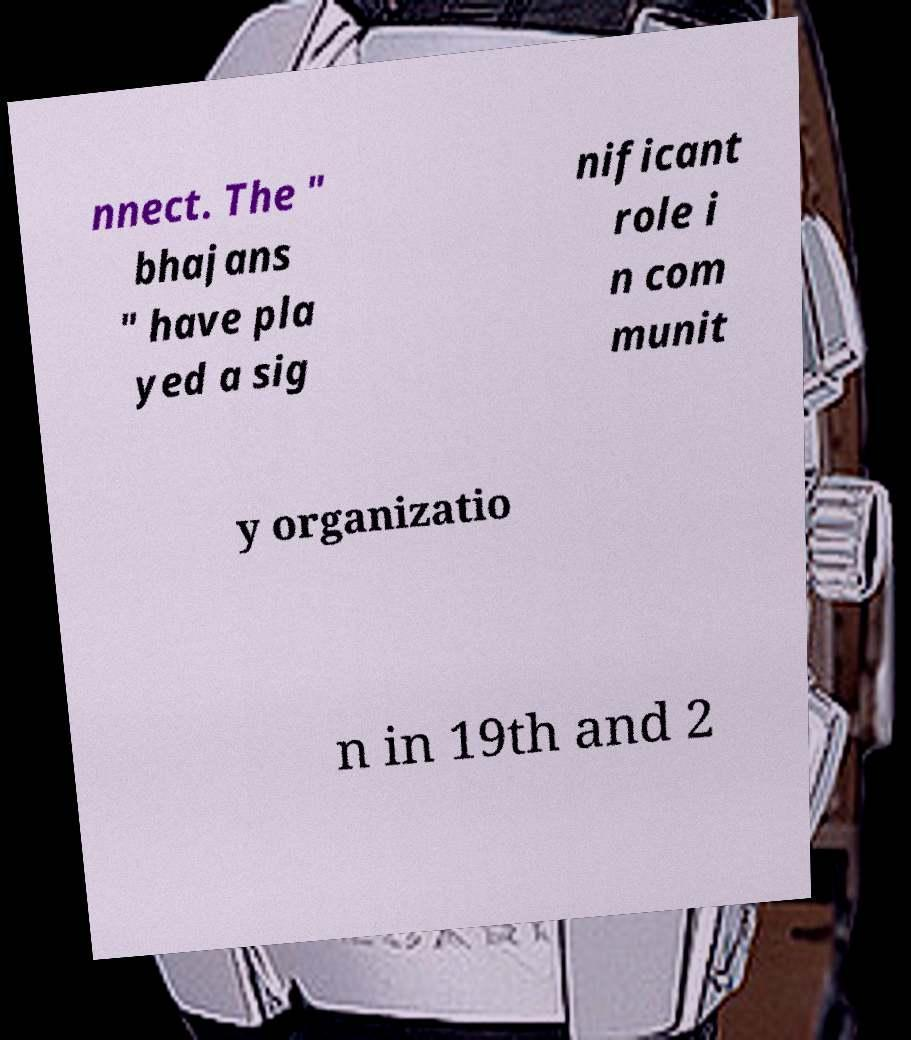Could you assist in decoding the text presented in this image and type it out clearly? nnect. The " bhajans " have pla yed a sig nificant role i n com munit y organizatio n in 19th and 2 